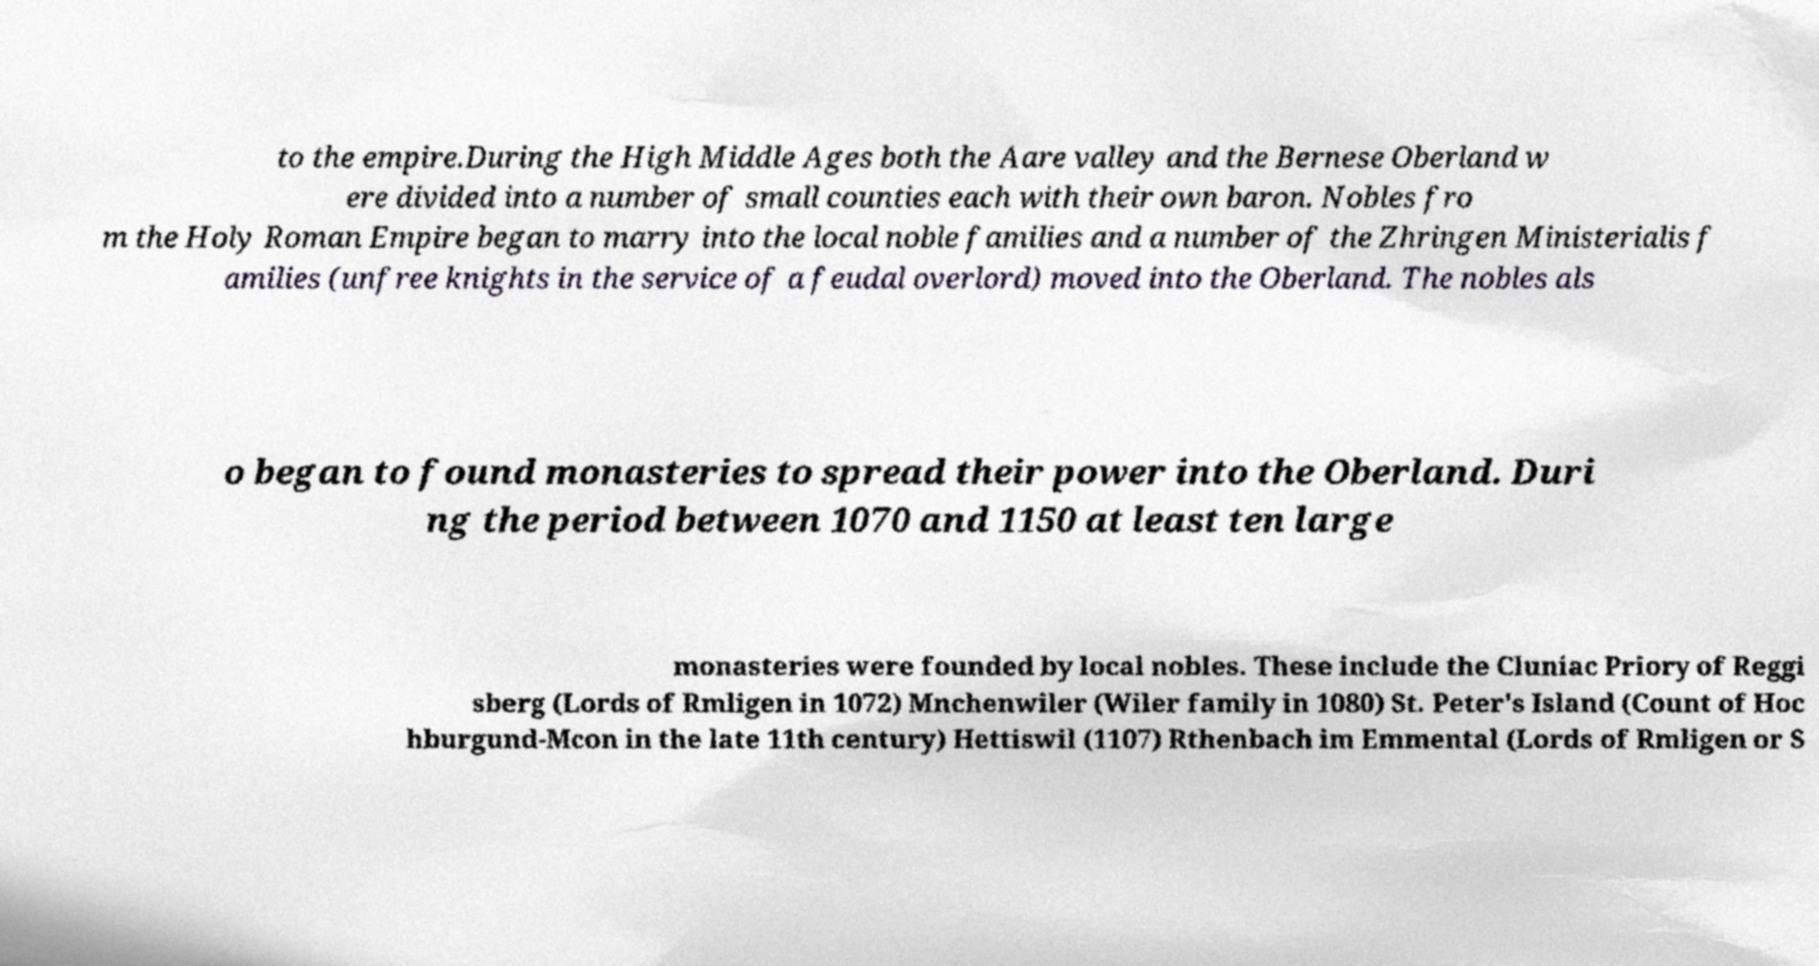Can you read and provide the text displayed in the image?This photo seems to have some interesting text. Can you extract and type it out for me? to the empire.During the High Middle Ages both the Aare valley and the Bernese Oberland w ere divided into a number of small counties each with their own baron. Nobles fro m the Holy Roman Empire began to marry into the local noble families and a number of the Zhringen Ministerialis f amilies (unfree knights in the service of a feudal overlord) moved into the Oberland. The nobles als o began to found monasteries to spread their power into the Oberland. Duri ng the period between 1070 and 1150 at least ten large monasteries were founded by local nobles. These include the Cluniac Priory of Reggi sberg (Lords of Rmligen in 1072) Mnchenwiler (Wiler family in 1080) St. Peter's Island (Count of Hoc hburgund-Mcon in the late 11th century) Hettiswil (1107) Rthenbach im Emmental (Lords of Rmligen or S 